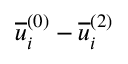<formula> <loc_0><loc_0><loc_500><loc_500>\overline { u } _ { i } ^ { ( 0 ) } - \overline { u } _ { i } ^ { ( 2 ) }</formula> 